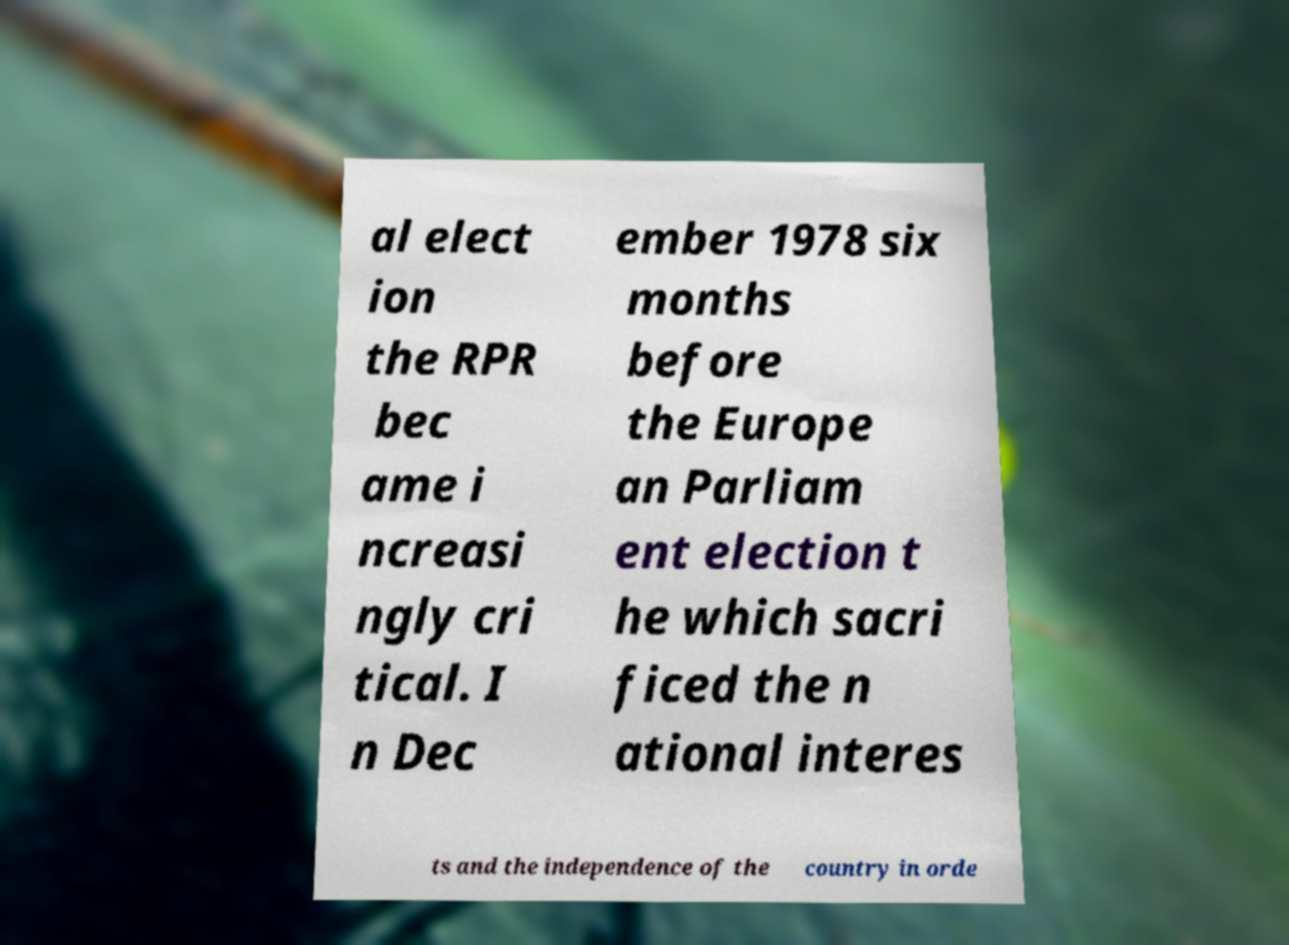What messages or text are displayed in this image? I need them in a readable, typed format. al elect ion the RPR bec ame i ncreasi ngly cri tical. I n Dec ember 1978 six months before the Europe an Parliam ent election t he which sacri ficed the n ational interes ts and the independence of the country in orde 